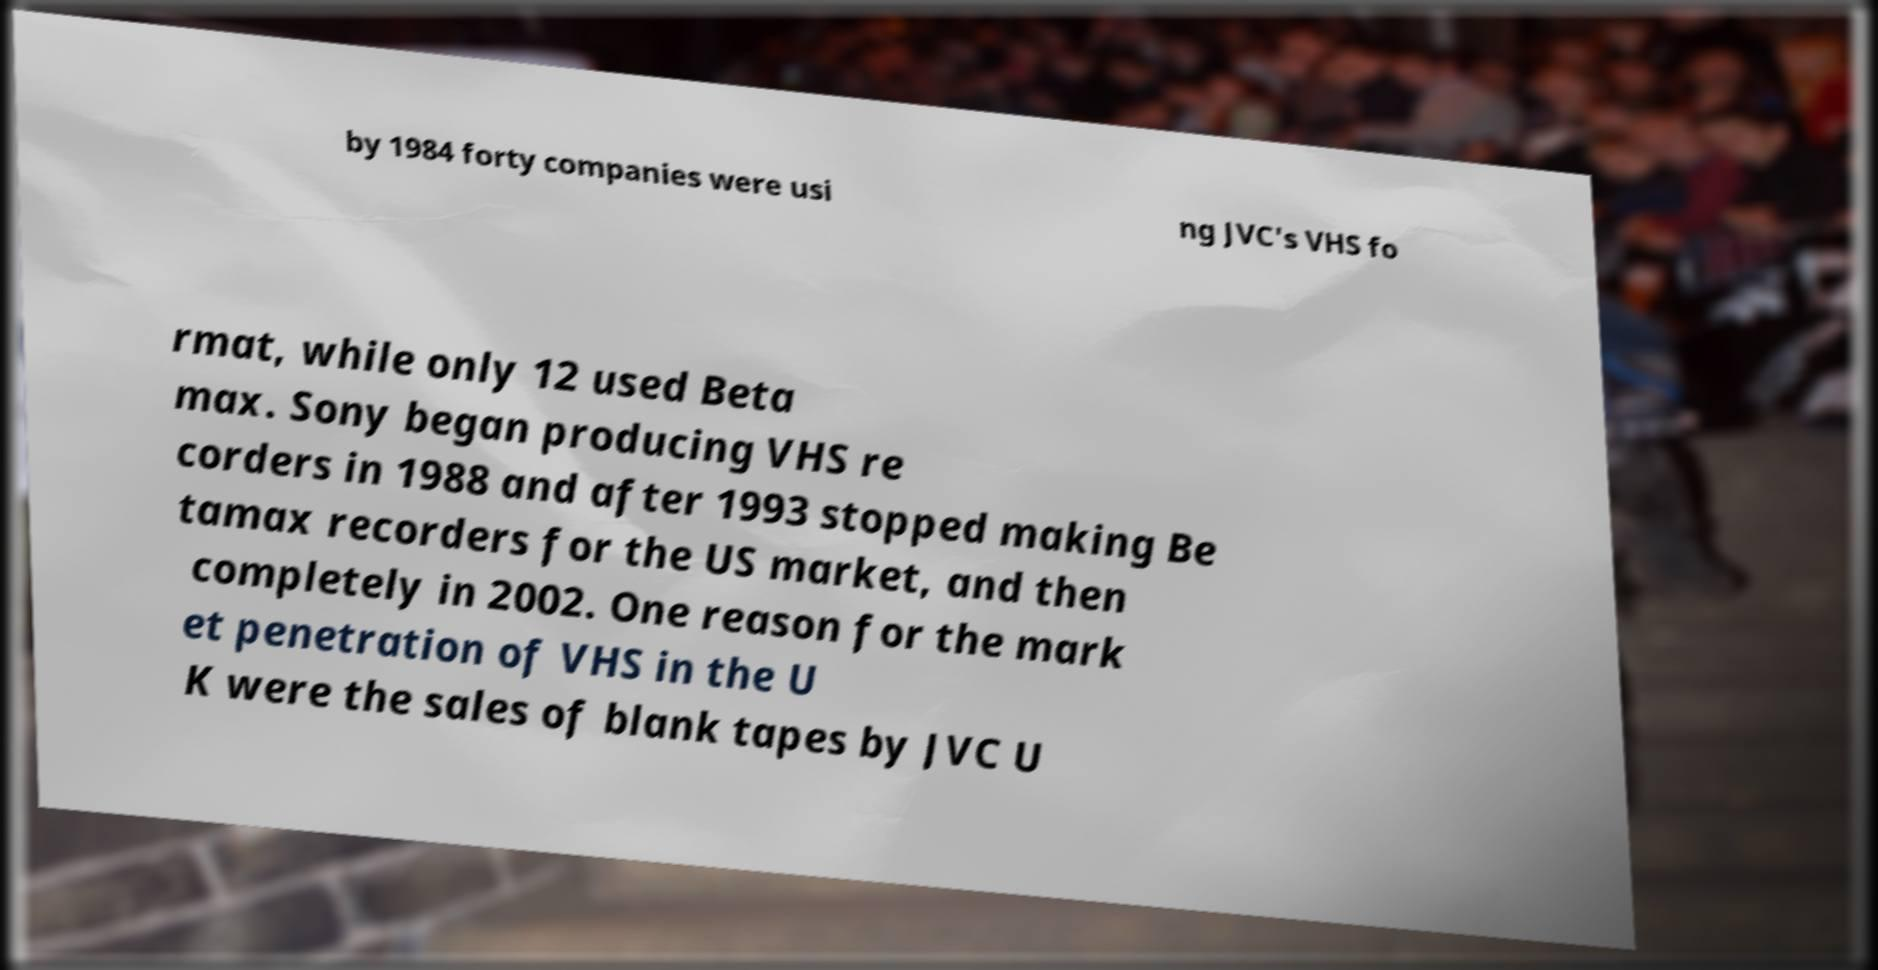Could you extract and type out the text from this image? by 1984 forty companies were usi ng JVC's VHS fo rmat, while only 12 used Beta max. Sony began producing VHS re corders in 1988 and after 1993 stopped making Be tamax recorders for the US market, and then completely in 2002. One reason for the mark et penetration of VHS in the U K were the sales of blank tapes by JVC U 